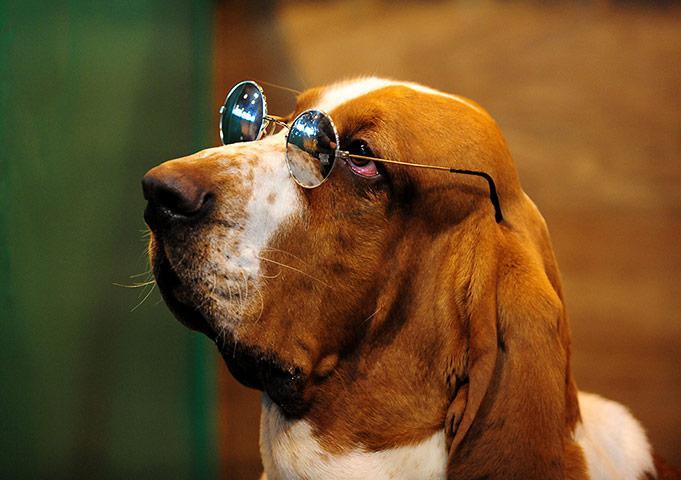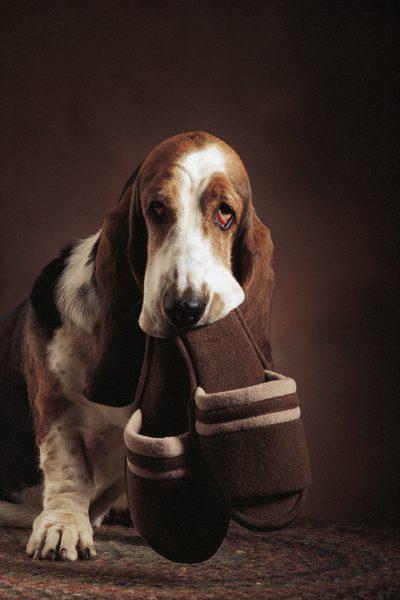The first image is the image on the left, the second image is the image on the right. Assess this claim about the two images: "A basset hound is sleeping on a platform facing the right, with one ear hanging down.". Correct or not? Answer yes or no. No. 